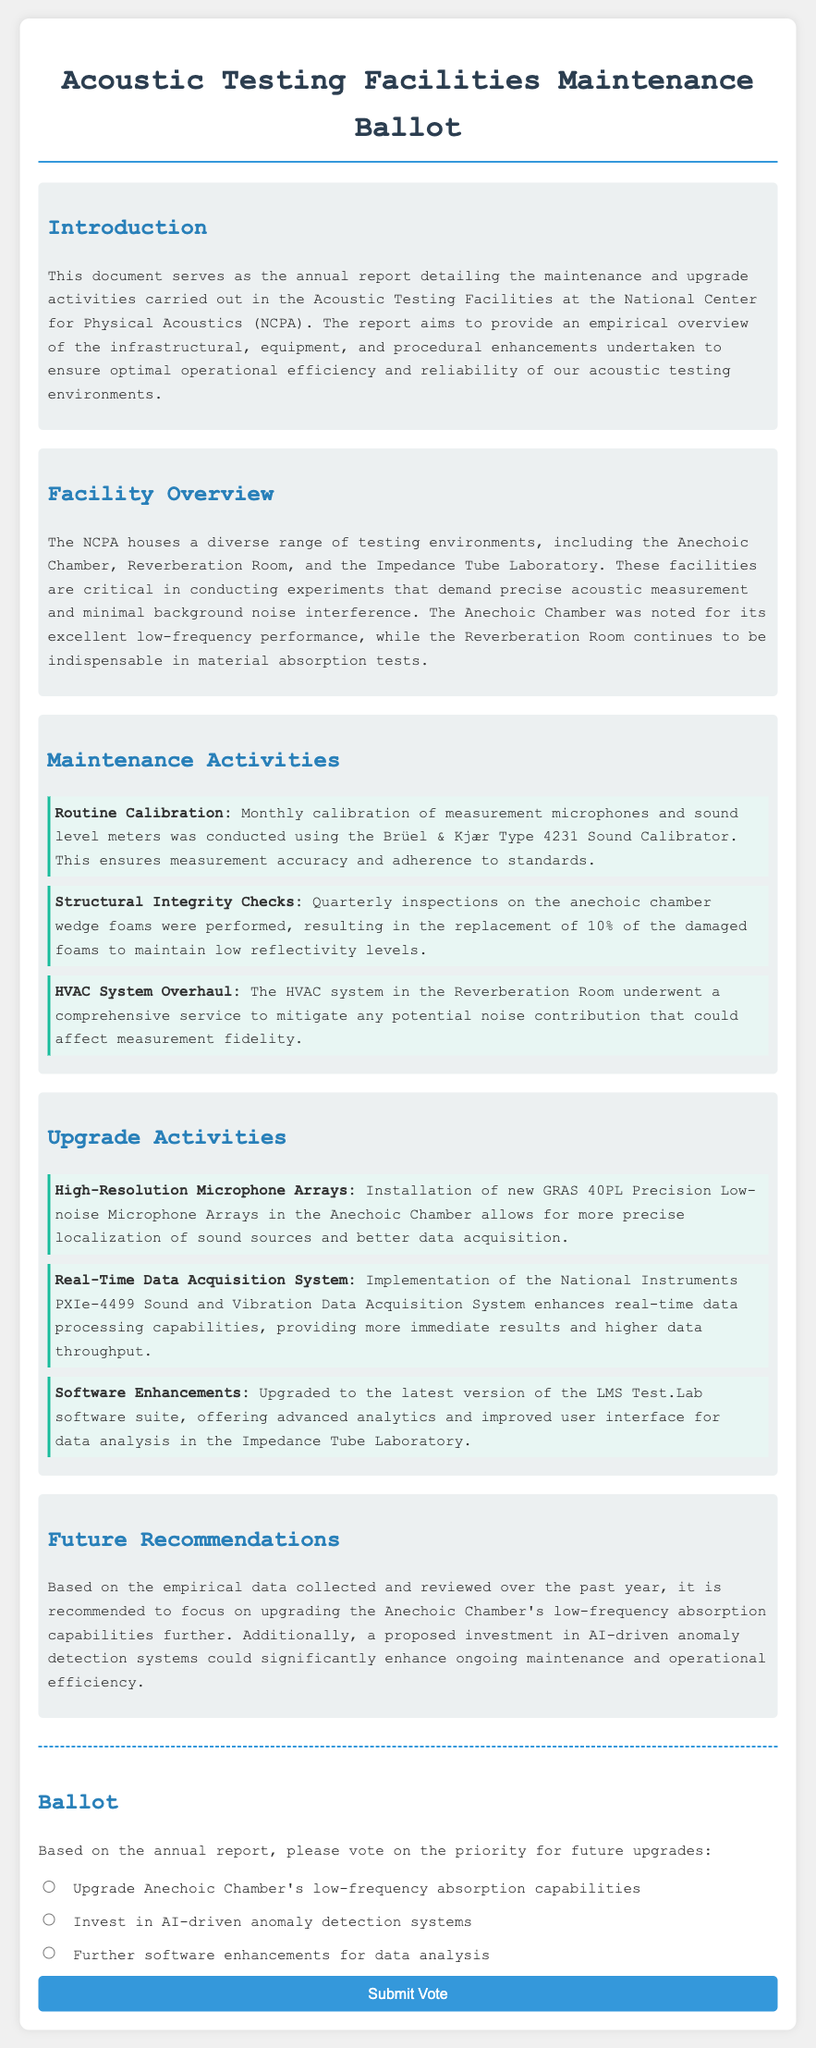What is the title of the document? The title is provided in the header of the document, summarizing its focus on maintenance and upgrades related to acoustic testing facilities.
Answer: Acoustic Testing Facilities Maintenance Ballot What facility has excellent low-frequency performance? This information is found in the Facility Overview section, highlighting the specific capabilities of the different testing environments.
Answer: Anechoic Chamber How often are routine calibrations conducted? The frequency of the maintenance activities is detailed in the Maintenance Activities section of the document.
Answer: Monthly What was replaced as part of the structural integrity checks? The specific item that was addressed during these checks is mentioned in the Maintenance Activities section, indicating the effort to uphold facility standards.
Answer: Wedge foams What new system was implemented for data acquisition? This refers to the upgrade activities described in the document, indicating advancements made to improve data processing capabilities.
Answer: National Instruments PXIe-4499 What does the report recommend for future upgrades? The recommendations based on empirical data gathering are listed in the Future Recommendations section, guiding future priorities for improvements.
Answer: Upgrade Anechoic Chamber's low-frequency absorption capabilities How many percentage of foam was replaced in the anechoic chamber? This specific detail about maintenance efforts is found within the maintenance activities, illustrating the extent of the work performed.
Answer: 10% What type of software enhancements were made? The details regarding the enhancements to software systems are found in the Upgrade Activities section, showing efforts to improve analysis capabilities.
Answer: LMS Test.Lab software suite 